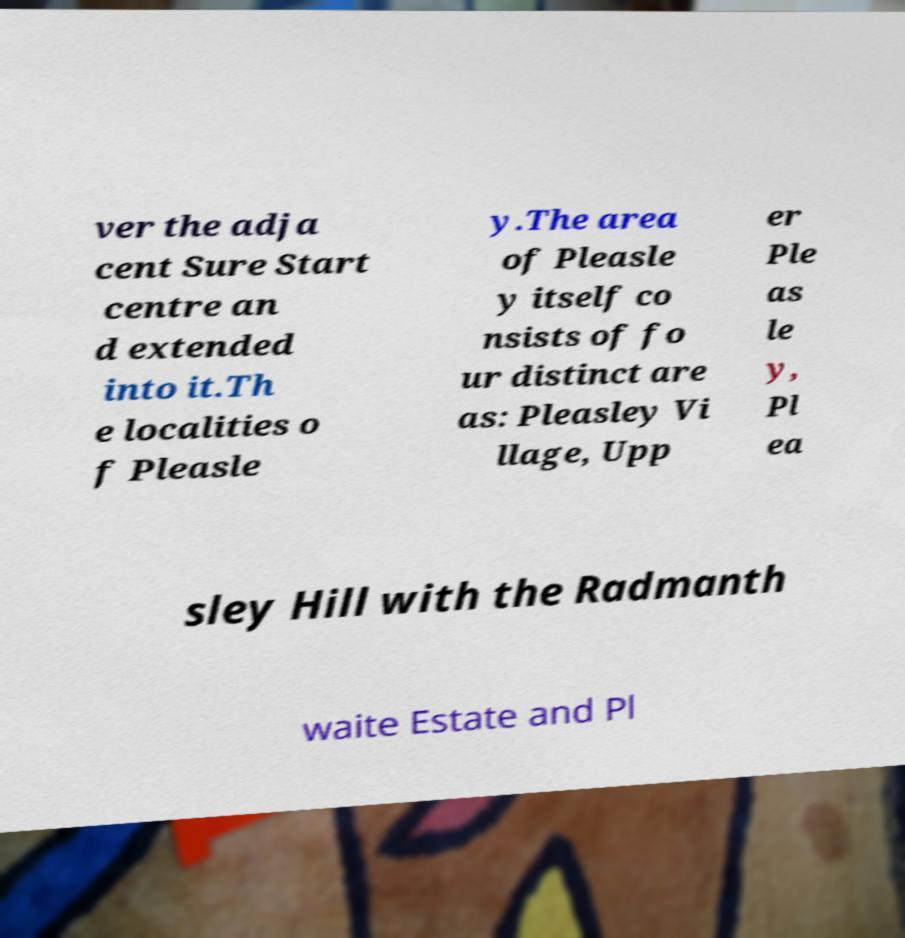What messages or text are displayed in this image? I need them in a readable, typed format. ver the adja cent Sure Start centre an d extended into it.Th e localities o f Pleasle y.The area of Pleasle y itself co nsists of fo ur distinct are as: Pleasley Vi llage, Upp er Ple as le y, Pl ea sley Hill with the Radmanth waite Estate and Pl 